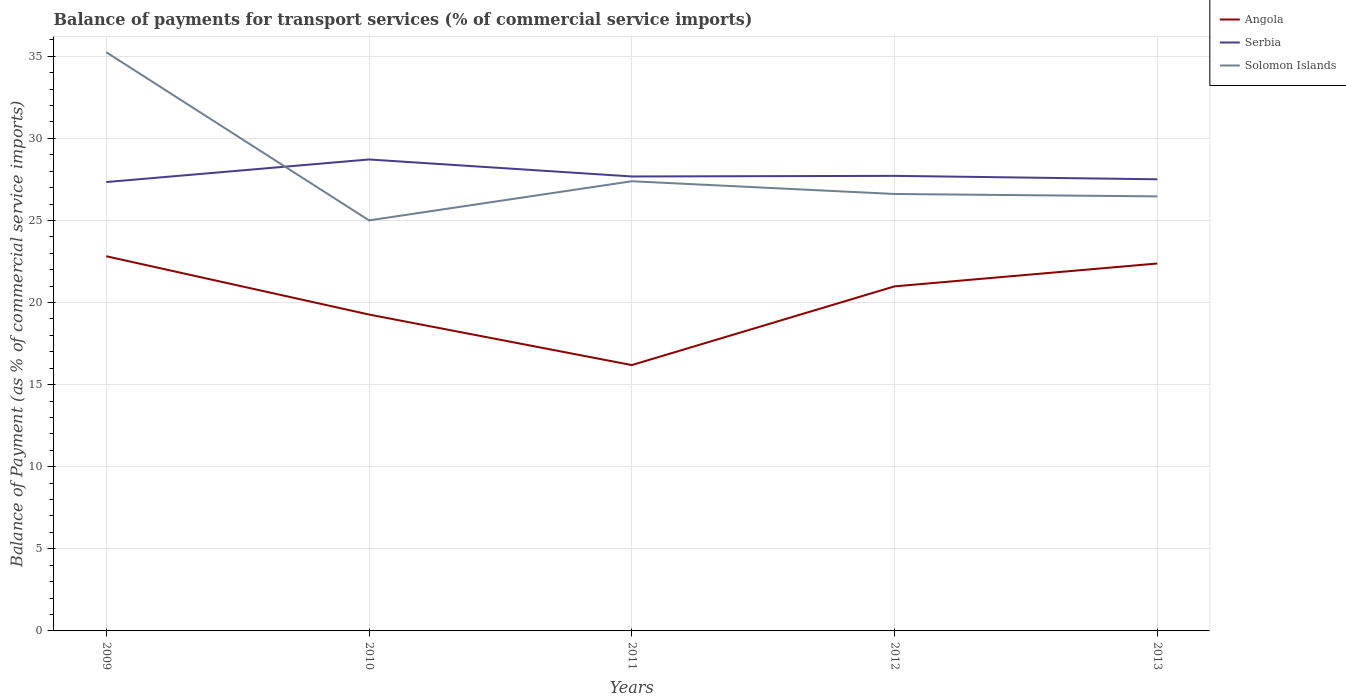Does the line corresponding to Serbia intersect with the line corresponding to Angola?
Provide a succinct answer. No. Across all years, what is the maximum balance of payments for transport services in Serbia?
Offer a terse response. 27.34. What is the total balance of payments for transport services in Angola in the graph?
Your response must be concise. 6.63. What is the difference between the highest and the second highest balance of payments for transport services in Serbia?
Give a very brief answer. 1.38. How many years are there in the graph?
Provide a succinct answer. 5. What is the difference between two consecutive major ticks on the Y-axis?
Provide a succinct answer. 5. Are the values on the major ticks of Y-axis written in scientific E-notation?
Provide a short and direct response. No. Does the graph contain any zero values?
Offer a terse response. No. Where does the legend appear in the graph?
Make the answer very short. Top right. How many legend labels are there?
Ensure brevity in your answer.  3. How are the legend labels stacked?
Your answer should be very brief. Vertical. What is the title of the graph?
Offer a terse response. Balance of payments for transport services (% of commercial service imports). Does "India" appear as one of the legend labels in the graph?
Keep it short and to the point. No. What is the label or title of the X-axis?
Ensure brevity in your answer.  Years. What is the label or title of the Y-axis?
Make the answer very short. Balance of Payment (as % of commercial service imports). What is the Balance of Payment (as % of commercial service imports) of Angola in 2009?
Make the answer very short. 22.82. What is the Balance of Payment (as % of commercial service imports) of Serbia in 2009?
Provide a short and direct response. 27.34. What is the Balance of Payment (as % of commercial service imports) of Solomon Islands in 2009?
Your answer should be compact. 35.25. What is the Balance of Payment (as % of commercial service imports) of Angola in 2010?
Your response must be concise. 19.27. What is the Balance of Payment (as % of commercial service imports) of Serbia in 2010?
Make the answer very short. 28.71. What is the Balance of Payment (as % of commercial service imports) of Solomon Islands in 2010?
Ensure brevity in your answer.  25. What is the Balance of Payment (as % of commercial service imports) in Angola in 2011?
Make the answer very short. 16.19. What is the Balance of Payment (as % of commercial service imports) of Serbia in 2011?
Ensure brevity in your answer.  27.68. What is the Balance of Payment (as % of commercial service imports) of Solomon Islands in 2011?
Your answer should be very brief. 27.39. What is the Balance of Payment (as % of commercial service imports) of Angola in 2012?
Keep it short and to the point. 20.98. What is the Balance of Payment (as % of commercial service imports) of Serbia in 2012?
Offer a very short reply. 27.72. What is the Balance of Payment (as % of commercial service imports) in Solomon Islands in 2012?
Ensure brevity in your answer.  26.61. What is the Balance of Payment (as % of commercial service imports) of Angola in 2013?
Your answer should be very brief. 22.38. What is the Balance of Payment (as % of commercial service imports) in Serbia in 2013?
Offer a terse response. 27.51. What is the Balance of Payment (as % of commercial service imports) in Solomon Islands in 2013?
Your answer should be compact. 26.47. Across all years, what is the maximum Balance of Payment (as % of commercial service imports) in Angola?
Offer a terse response. 22.82. Across all years, what is the maximum Balance of Payment (as % of commercial service imports) of Serbia?
Ensure brevity in your answer.  28.71. Across all years, what is the maximum Balance of Payment (as % of commercial service imports) of Solomon Islands?
Provide a short and direct response. 35.25. Across all years, what is the minimum Balance of Payment (as % of commercial service imports) in Angola?
Offer a terse response. 16.19. Across all years, what is the minimum Balance of Payment (as % of commercial service imports) in Serbia?
Make the answer very short. 27.34. Across all years, what is the minimum Balance of Payment (as % of commercial service imports) of Solomon Islands?
Provide a short and direct response. 25. What is the total Balance of Payment (as % of commercial service imports) in Angola in the graph?
Keep it short and to the point. 101.64. What is the total Balance of Payment (as % of commercial service imports) of Serbia in the graph?
Offer a very short reply. 138.95. What is the total Balance of Payment (as % of commercial service imports) in Solomon Islands in the graph?
Your response must be concise. 140.71. What is the difference between the Balance of Payment (as % of commercial service imports) in Angola in 2009 and that in 2010?
Make the answer very short. 3.55. What is the difference between the Balance of Payment (as % of commercial service imports) of Serbia in 2009 and that in 2010?
Your response must be concise. -1.38. What is the difference between the Balance of Payment (as % of commercial service imports) in Solomon Islands in 2009 and that in 2010?
Your response must be concise. 10.24. What is the difference between the Balance of Payment (as % of commercial service imports) in Angola in 2009 and that in 2011?
Offer a terse response. 6.63. What is the difference between the Balance of Payment (as % of commercial service imports) in Serbia in 2009 and that in 2011?
Your answer should be very brief. -0.34. What is the difference between the Balance of Payment (as % of commercial service imports) of Solomon Islands in 2009 and that in 2011?
Your answer should be compact. 7.86. What is the difference between the Balance of Payment (as % of commercial service imports) in Angola in 2009 and that in 2012?
Make the answer very short. 1.83. What is the difference between the Balance of Payment (as % of commercial service imports) in Serbia in 2009 and that in 2012?
Provide a succinct answer. -0.38. What is the difference between the Balance of Payment (as % of commercial service imports) in Solomon Islands in 2009 and that in 2012?
Provide a succinct answer. 8.63. What is the difference between the Balance of Payment (as % of commercial service imports) of Angola in 2009 and that in 2013?
Keep it short and to the point. 0.44. What is the difference between the Balance of Payment (as % of commercial service imports) in Serbia in 2009 and that in 2013?
Your response must be concise. -0.17. What is the difference between the Balance of Payment (as % of commercial service imports) of Solomon Islands in 2009 and that in 2013?
Your answer should be compact. 8.78. What is the difference between the Balance of Payment (as % of commercial service imports) in Angola in 2010 and that in 2011?
Give a very brief answer. 3.08. What is the difference between the Balance of Payment (as % of commercial service imports) of Serbia in 2010 and that in 2011?
Offer a very short reply. 1.03. What is the difference between the Balance of Payment (as % of commercial service imports) of Solomon Islands in 2010 and that in 2011?
Your response must be concise. -2.38. What is the difference between the Balance of Payment (as % of commercial service imports) in Angola in 2010 and that in 2012?
Provide a short and direct response. -1.71. What is the difference between the Balance of Payment (as % of commercial service imports) of Serbia in 2010 and that in 2012?
Your answer should be very brief. 1. What is the difference between the Balance of Payment (as % of commercial service imports) in Solomon Islands in 2010 and that in 2012?
Offer a very short reply. -1.61. What is the difference between the Balance of Payment (as % of commercial service imports) of Angola in 2010 and that in 2013?
Your answer should be compact. -3.11. What is the difference between the Balance of Payment (as % of commercial service imports) in Serbia in 2010 and that in 2013?
Provide a short and direct response. 1.21. What is the difference between the Balance of Payment (as % of commercial service imports) in Solomon Islands in 2010 and that in 2013?
Offer a very short reply. -1.46. What is the difference between the Balance of Payment (as % of commercial service imports) of Angola in 2011 and that in 2012?
Offer a terse response. -4.79. What is the difference between the Balance of Payment (as % of commercial service imports) in Serbia in 2011 and that in 2012?
Make the answer very short. -0.04. What is the difference between the Balance of Payment (as % of commercial service imports) of Solomon Islands in 2011 and that in 2012?
Provide a succinct answer. 0.78. What is the difference between the Balance of Payment (as % of commercial service imports) of Angola in 2011 and that in 2013?
Your answer should be compact. -6.19. What is the difference between the Balance of Payment (as % of commercial service imports) of Serbia in 2011 and that in 2013?
Provide a succinct answer. 0.17. What is the difference between the Balance of Payment (as % of commercial service imports) of Solomon Islands in 2011 and that in 2013?
Your response must be concise. 0.92. What is the difference between the Balance of Payment (as % of commercial service imports) in Angola in 2012 and that in 2013?
Provide a short and direct response. -1.39. What is the difference between the Balance of Payment (as % of commercial service imports) of Serbia in 2012 and that in 2013?
Your response must be concise. 0.21. What is the difference between the Balance of Payment (as % of commercial service imports) of Solomon Islands in 2012 and that in 2013?
Your answer should be compact. 0.15. What is the difference between the Balance of Payment (as % of commercial service imports) of Angola in 2009 and the Balance of Payment (as % of commercial service imports) of Serbia in 2010?
Provide a short and direct response. -5.89. What is the difference between the Balance of Payment (as % of commercial service imports) of Angola in 2009 and the Balance of Payment (as % of commercial service imports) of Solomon Islands in 2010?
Offer a terse response. -2.18. What is the difference between the Balance of Payment (as % of commercial service imports) of Serbia in 2009 and the Balance of Payment (as % of commercial service imports) of Solomon Islands in 2010?
Provide a short and direct response. 2.33. What is the difference between the Balance of Payment (as % of commercial service imports) of Angola in 2009 and the Balance of Payment (as % of commercial service imports) of Serbia in 2011?
Give a very brief answer. -4.86. What is the difference between the Balance of Payment (as % of commercial service imports) of Angola in 2009 and the Balance of Payment (as % of commercial service imports) of Solomon Islands in 2011?
Provide a short and direct response. -4.57. What is the difference between the Balance of Payment (as % of commercial service imports) in Serbia in 2009 and the Balance of Payment (as % of commercial service imports) in Solomon Islands in 2011?
Provide a short and direct response. -0.05. What is the difference between the Balance of Payment (as % of commercial service imports) in Angola in 2009 and the Balance of Payment (as % of commercial service imports) in Serbia in 2012?
Provide a succinct answer. -4.9. What is the difference between the Balance of Payment (as % of commercial service imports) of Angola in 2009 and the Balance of Payment (as % of commercial service imports) of Solomon Islands in 2012?
Provide a succinct answer. -3.79. What is the difference between the Balance of Payment (as % of commercial service imports) in Serbia in 2009 and the Balance of Payment (as % of commercial service imports) in Solomon Islands in 2012?
Make the answer very short. 0.73. What is the difference between the Balance of Payment (as % of commercial service imports) in Angola in 2009 and the Balance of Payment (as % of commercial service imports) in Serbia in 2013?
Provide a short and direct response. -4.69. What is the difference between the Balance of Payment (as % of commercial service imports) in Angola in 2009 and the Balance of Payment (as % of commercial service imports) in Solomon Islands in 2013?
Your response must be concise. -3.65. What is the difference between the Balance of Payment (as % of commercial service imports) in Serbia in 2009 and the Balance of Payment (as % of commercial service imports) in Solomon Islands in 2013?
Provide a succinct answer. 0.87. What is the difference between the Balance of Payment (as % of commercial service imports) in Angola in 2010 and the Balance of Payment (as % of commercial service imports) in Serbia in 2011?
Your answer should be very brief. -8.41. What is the difference between the Balance of Payment (as % of commercial service imports) of Angola in 2010 and the Balance of Payment (as % of commercial service imports) of Solomon Islands in 2011?
Offer a terse response. -8.12. What is the difference between the Balance of Payment (as % of commercial service imports) of Serbia in 2010 and the Balance of Payment (as % of commercial service imports) of Solomon Islands in 2011?
Offer a very short reply. 1.33. What is the difference between the Balance of Payment (as % of commercial service imports) in Angola in 2010 and the Balance of Payment (as % of commercial service imports) in Serbia in 2012?
Provide a succinct answer. -8.45. What is the difference between the Balance of Payment (as % of commercial service imports) in Angola in 2010 and the Balance of Payment (as % of commercial service imports) in Solomon Islands in 2012?
Offer a very short reply. -7.34. What is the difference between the Balance of Payment (as % of commercial service imports) of Serbia in 2010 and the Balance of Payment (as % of commercial service imports) of Solomon Islands in 2012?
Your answer should be very brief. 2.1. What is the difference between the Balance of Payment (as % of commercial service imports) in Angola in 2010 and the Balance of Payment (as % of commercial service imports) in Serbia in 2013?
Ensure brevity in your answer.  -8.24. What is the difference between the Balance of Payment (as % of commercial service imports) of Angola in 2010 and the Balance of Payment (as % of commercial service imports) of Solomon Islands in 2013?
Provide a short and direct response. -7.2. What is the difference between the Balance of Payment (as % of commercial service imports) in Serbia in 2010 and the Balance of Payment (as % of commercial service imports) in Solomon Islands in 2013?
Offer a very short reply. 2.25. What is the difference between the Balance of Payment (as % of commercial service imports) of Angola in 2011 and the Balance of Payment (as % of commercial service imports) of Serbia in 2012?
Give a very brief answer. -11.52. What is the difference between the Balance of Payment (as % of commercial service imports) of Angola in 2011 and the Balance of Payment (as % of commercial service imports) of Solomon Islands in 2012?
Offer a terse response. -10.42. What is the difference between the Balance of Payment (as % of commercial service imports) in Serbia in 2011 and the Balance of Payment (as % of commercial service imports) in Solomon Islands in 2012?
Give a very brief answer. 1.07. What is the difference between the Balance of Payment (as % of commercial service imports) in Angola in 2011 and the Balance of Payment (as % of commercial service imports) in Serbia in 2013?
Provide a short and direct response. -11.31. What is the difference between the Balance of Payment (as % of commercial service imports) in Angola in 2011 and the Balance of Payment (as % of commercial service imports) in Solomon Islands in 2013?
Your response must be concise. -10.27. What is the difference between the Balance of Payment (as % of commercial service imports) in Serbia in 2011 and the Balance of Payment (as % of commercial service imports) in Solomon Islands in 2013?
Your answer should be very brief. 1.21. What is the difference between the Balance of Payment (as % of commercial service imports) in Angola in 2012 and the Balance of Payment (as % of commercial service imports) in Serbia in 2013?
Your answer should be very brief. -6.52. What is the difference between the Balance of Payment (as % of commercial service imports) of Angola in 2012 and the Balance of Payment (as % of commercial service imports) of Solomon Islands in 2013?
Your response must be concise. -5.48. What is the difference between the Balance of Payment (as % of commercial service imports) in Serbia in 2012 and the Balance of Payment (as % of commercial service imports) in Solomon Islands in 2013?
Your response must be concise. 1.25. What is the average Balance of Payment (as % of commercial service imports) in Angola per year?
Ensure brevity in your answer.  20.33. What is the average Balance of Payment (as % of commercial service imports) in Serbia per year?
Your answer should be compact. 27.79. What is the average Balance of Payment (as % of commercial service imports) in Solomon Islands per year?
Offer a very short reply. 28.14. In the year 2009, what is the difference between the Balance of Payment (as % of commercial service imports) in Angola and Balance of Payment (as % of commercial service imports) in Serbia?
Give a very brief answer. -4.52. In the year 2009, what is the difference between the Balance of Payment (as % of commercial service imports) in Angola and Balance of Payment (as % of commercial service imports) in Solomon Islands?
Your response must be concise. -12.43. In the year 2009, what is the difference between the Balance of Payment (as % of commercial service imports) in Serbia and Balance of Payment (as % of commercial service imports) in Solomon Islands?
Offer a very short reply. -7.91. In the year 2010, what is the difference between the Balance of Payment (as % of commercial service imports) of Angola and Balance of Payment (as % of commercial service imports) of Serbia?
Ensure brevity in your answer.  -9.44. In the year 2010, what is the difference between the Balance of Payment (as % of commercial service imports) in Angola and Balance of Payment (as % of commercial service imports) in Solomon Islands?
Keep it short and to the point. -5.73. In the year 2010, what is the difference between the Balance of Payment (as % of commercial service imports) of Serbia and Balance of Payment (as % of commercial service imports) of Solomon Islands?
Your response must be concise. 3.71. In the year 2011, what is the difference between the Balance of Payment (as % of commercial service imports) of Angola and Balance of Payment (as % of commercial service imports) of Serbia?
Ensure brevity in your answer.  -11.49. In the year 2011, what is the difference between the Balance of Payment (as % of commercial service imports) of Angola and Balance of Payment (as % of commercial service imports) of Solomon Islands?
Offer a terse response. -11.2. In the year 2011, what is the difference between the Balance of Payment (as % of commercial service imports) of Serbia and Balance of Payment (as % of commercial service imports) of Solomon Islands?
Provide a short and direct response. 0.29. In the year 2012, what is the difference between the Balance of Payment (as % of commercial service imports) of Angola and Balance of Payment (as % of commercial service imports) of Serbia?
Provide a succinct answer. -6.73. In the year 2012, what is the difference between the Balance of Payment (as % of commercial service imports) in Angola and Balance of Payment (as % of commercial service imports) in Solomon Islands?
Your answer should be very brief. -5.63. In the year 2012, what is the difference between the Balance of Payment (as % of commercial service imports) of Serbia and Balance of Payment (as % of commercial service imports) of Solomon Islands?
Keep it short and to the point. 1.1. In the year 2013, what is the difference between the Balance of Payment (as % of commercial service imports) of Angola and Balance of Payment (as % of commercial service imports) of Serbia?
Offer a terse response. -5.13. In the year 2013, what is the difference between the Balance of Payment (as % of commercial service imports) in Angola and Balance of Payment (as % of commercial service imports) in Solomon Islands?
Offer a terse response. -4.09. In the year 2013, what is the difference between the Balance of Payment (as % of commercial service imports) in Serbia and Balance of Payment (as % of commercial service imports) in Solomon Islands?
Offer a very short reply. 1.04. What is the ratio of the Balance of Payment (as % of commercial service imports) in Angola in 2009 to that in 2010?
Provide a succinct answer. 1.18. What is the ratio of the Balance of Payment (as % of commercial service imports) in Serbia in 2009 to that in 2010?
Keep it short and to the point. 0.95. What is the ratio of the Balance of Payment (as % of commercial service imports) in Solomon Islands in 2009 to that in 2010?
Provide a short and direct response. 1.41. What is the ratio of the Balance of Payment (as % of commercial service imports) of Angola in 2009 to that in 2011?
Ensure brevity in your answer.  1.41. What is the ratio of the Balance of Payment (as % of commercial service imports) of Serbia in 2009 to that in 2011?
Give a very brief answer. 0.99. What is the ratio of the Balance of Payment (as % of commercial service imports) of Solomon Islands in 2009 to that in 2011?
Offer a very short reply. 1.29. What is the ratio of the Balance of Payment (as % of commercial service imports) of Angola in 2009 to that in 2012?
Provide a succinct answer. 1.09. What is the ratio of the Balance of Payment (as % of commercial service imports) of Serbia in 2009 to that in 2012?
Your response must be concise. 0.99. What is the ratio of the Balance of Payment (as % of commercial service imports) of Solomon Islands in 2009 to that in 2012?
Your response must be concise. 1.32. What is the ratio of the Balance of Payment (as % of commercial service imports) of Angola in 2009 to that in 2013?
Provide a short and direct response. 1.02. What is the ratio of the Balance of Payment (as % of commercial service imports) of Serbia in 2009 to that in 2013?
Provide a short and direct response. 0.99. What is the ratio of the Balance of Payment (as % of commercial service imports) in Solomon Islands in 2009 to that in 2013?
Make the answer very short. 1.33. What is the ratio of the Balance of Payment (as % of commercial service imports) in Angola in 2010 to that in 2011?
Make the answer very short. 1.19. What is the ratio of the Balance of Payment (as % of commercial service imports) in Serbia in 2010 to that in 2011?
Offer a very short reply. 1.04. What is the ratio of the Balance of Payment (as % of commercial service imports) of Solomon Islands in 2010 to that in 2011?
Make the answer very short. 0.91. What is the ratio of the Balance of Payment (as % of commercial service imports) of Angola in 2010 to that in 2012?
Make the answer very short. 0.92. What is the ratio of the Balance of Payment (as % of commercial service imports) in Serbia in 2010 to that in 2012?
Provide a succinct answer. 1.04. What is the ratio of the Balance of Payment (as % of commercial service imports) of Solomon Islands in 2010 to that in 2012?
Your answer should be compact. 0.94. What is the ratio of the Balance of Payment (as % of commercial service imports) of Angola in 2010 to that in 2013?
Offer a very short reply. 0.86. What is the ratio of the Balance of Payment (as % of commercial service imports) of Serbia in 2010 to that in 2013?
Your answer should be very brief. 1.04. What is the ratio of the Balance of Payment (as % of commercial service imports) of Solomon Islands in 2010 to that in 2013?
Ensure brevity in your answer.  0.94. What is the ratio of the Balance of Payment (as % of commercial service imports) in Angola in 2011 to that in 2012?
Your answer should be compact. 0.77. What is the ratio of the Balance of Payment (as % of commercial service imports) in Serbia in 2011 to that in 2012?
Offer a very short reply. 1. What is the ratio of the Balance of Payment (as % of commercial service imports) of Solomon Islands in 2011 to that in 2012?
Provide a short and direct response. 1.03. What is the ratio of the Balance of Payment (as % of commercial service imports) in Angola in 2011 to that in 2013?
Your answer should be very brief. 0.72. What is the ratio of the Balance of Payment (as % of commercial service imports) of Solomon Islands in 2011 to that in 2013?
Ensure brevity in your answer.  1.03. What is the ratio of the Balance of Payment (as % of commercial service imports) of Angola in 2012 to that in 2013?
Ensure brevity in your answer.  0.94. What is the ratio of the Balance of Payment (as % of commercial service imports) in Serbia in 2012 to that in 2013?
Your response must be concise. 1.01. What is the difference between the highest and the second highest Balance of Payment (as % of commercial service imports) in Angola?
Ensure brevity in your answer.  0.44. What is the difference between the highest and the second highest Balance of Payment (as % of commercial service imports) of Serbia?
Your response must be concise. 1. What is the difference between the highest and the second highest Balance of Payment (as % of commercial service imports) in Solomon Islands?
Offer a terse response. 7.86. What is the difference between the highest and the lowest Balance of Payment (as % of commercial service imports) in Angola?
Make the answer very short. 6.63. What is the difference between the highest and the lowest Balance of Payment (as % of commercial service imports) of Serbia?
Offer a terse response. 1.38. What is the difference between the highest and the lowest Balance of Payment (as % of commercial service imports) of Solomon Islands?
Keep it short and to the point. 10.24. 